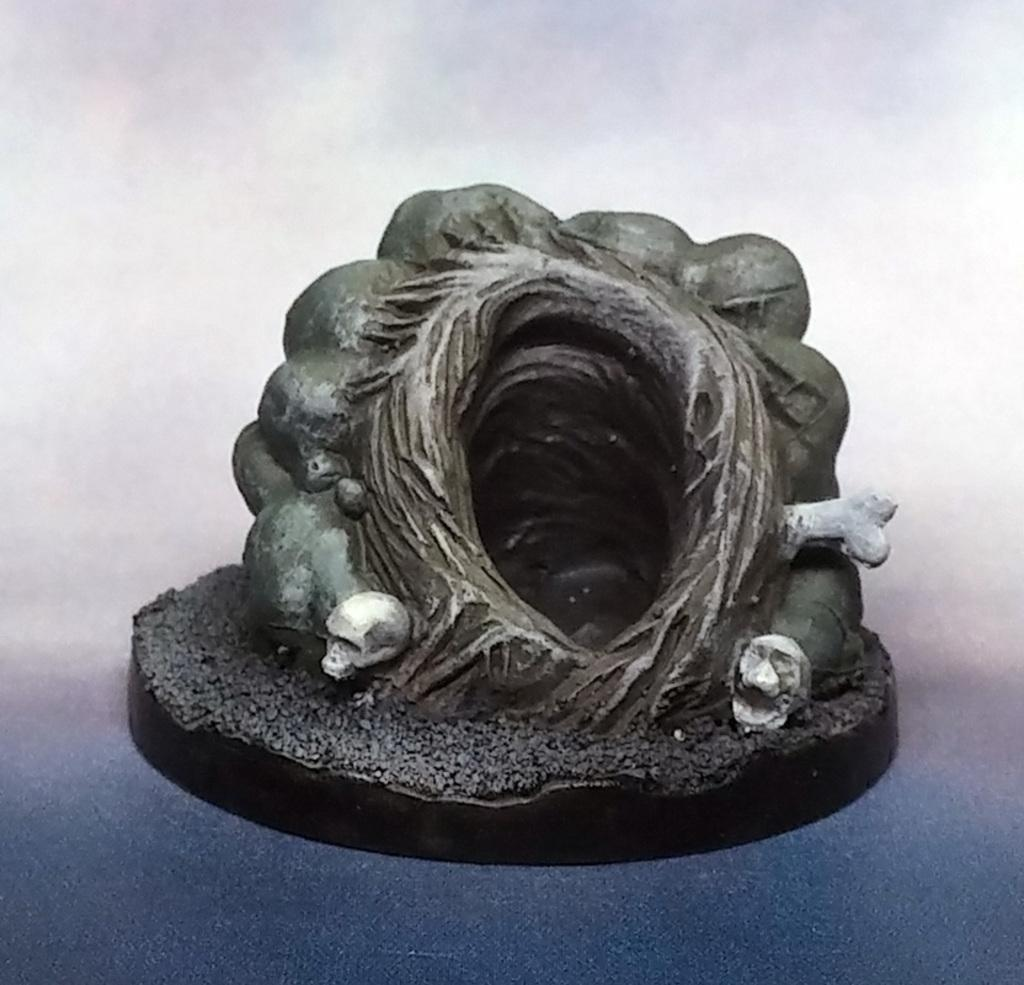What can be said about the nature of the image? The image is edited. What color is the background of the image? The background of the image is gray in color. What is the main subject in the middle of the image? There is a sculpture in the middle of the image. Can you describe the woman wearing a sock in the image? There is no woman or sock present in the image; it features a sculpture in a gray background. 